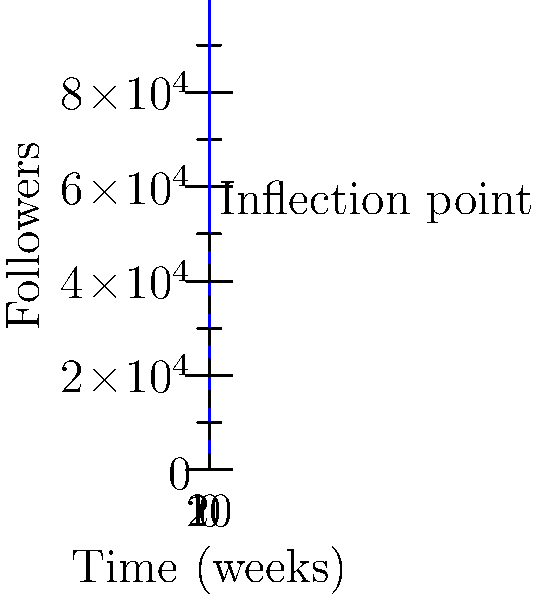As your social media following grows, you notice it follows a logistic growth curve. The number of followers $f(t)$ after $t$ weeks is given by the function:

$$f(t) = \frac{100000}{1 + e^{-0.5(t-10)}}$$

Find the inflection point of this curve, which represents the time when your follower growth rate changes from increasing to decreasing. How many followers do you have at this point? To find the inflection point, we need to follow these steps:

1) The inflection point occurs where the second derivative of the function equals zero.

2) First, let's find the first derivative:
   $$f'(t) = \frac{50000e^{-0.5(t-10)}}{(1 + e^{-0.5(t-10)})^2}$$

3) Now, let's find the second derivative:
   $$f''(t) = \frac{25000e^{-0.5(t-10)}(e^{-0.5(t-10)} - 1)}{(1 + e^{-0.5(t-10)})^3}$$

4) Set the second derivative equal to zero and solve for t:
   $$f''(t) = 0$$
   $$\frac{25000e^{-0.5(t-10)}(e^{-0.5(t-10)} - 1)}{(1 + e^{-0.5(t-10)})^3} = 0$$

   This equation is satisfied when $e^{-0.5(t-10)} - 1 = 0$
   $e^{-0.5(t-10)} = 1$
   $-0.5(t-10) = 0$
   $t = 10$

5) Now that we know the inflection point occurs at $t = 10$, let's find the number of followers at this point:

   $$f(10) = \frac{100000}{1 + e^{-0.5(10-10)}} = \frac{100000}{1 + e^0} = \frac{100000}{2} = 50000$$

Therefore, the inflection point occurs at 10 weeks, when you have 50,000 followers.
Answer: 10 weeks, 50,000 followers 